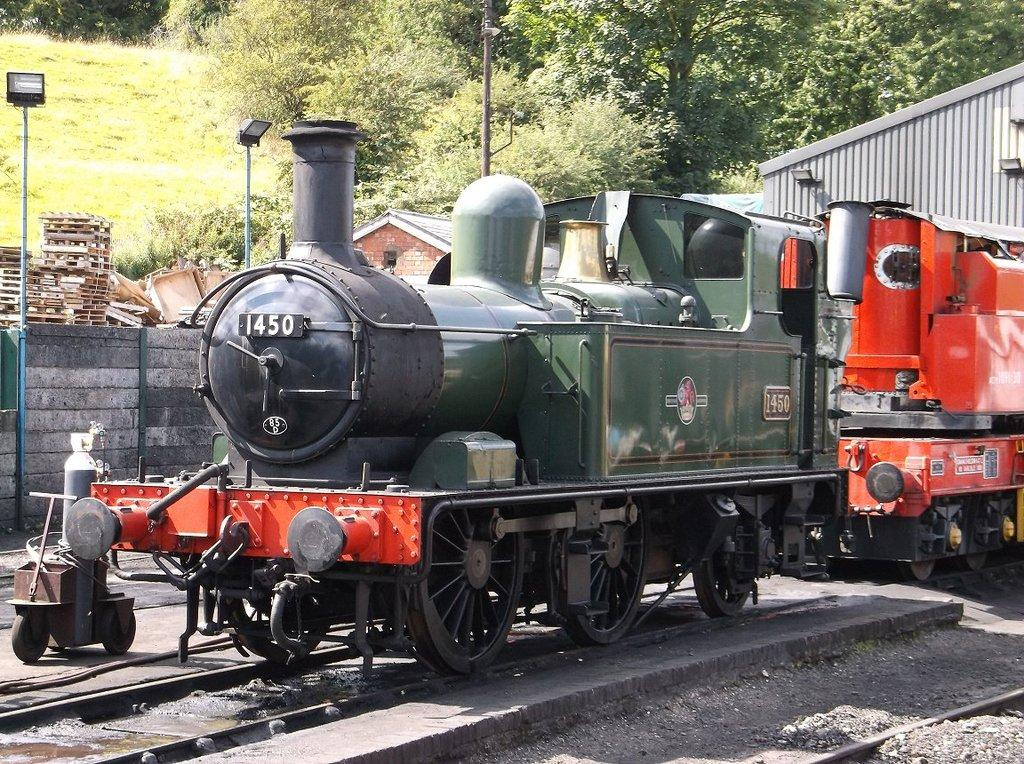<image>
Provide a brief description of the given image. The head of a train with the number 1450 written on it 